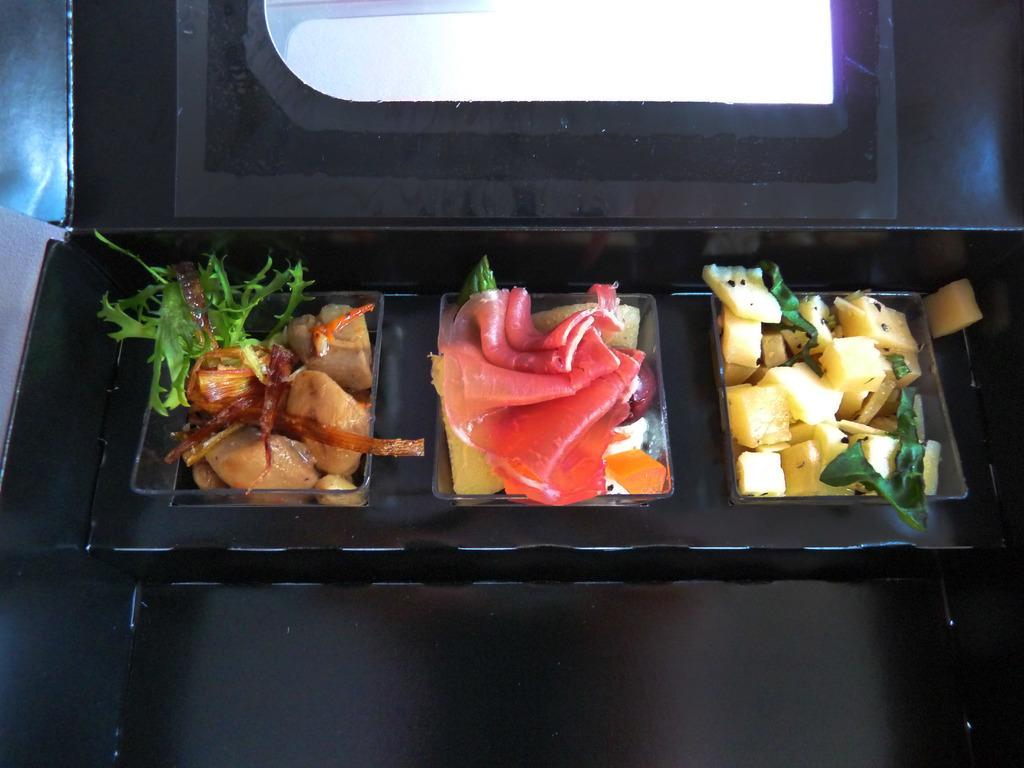What type of food can be seen in the image? There are potatoes, meat, and salad in the image. How are the potatoes, meat, and salad arranged in the image? The potatoes, meat, and salad are placed separately inside a box. What type of iron can be seen in the image? There is no iron present in the image; it features potatoes, meat, and salad arranged separately inside a box. 